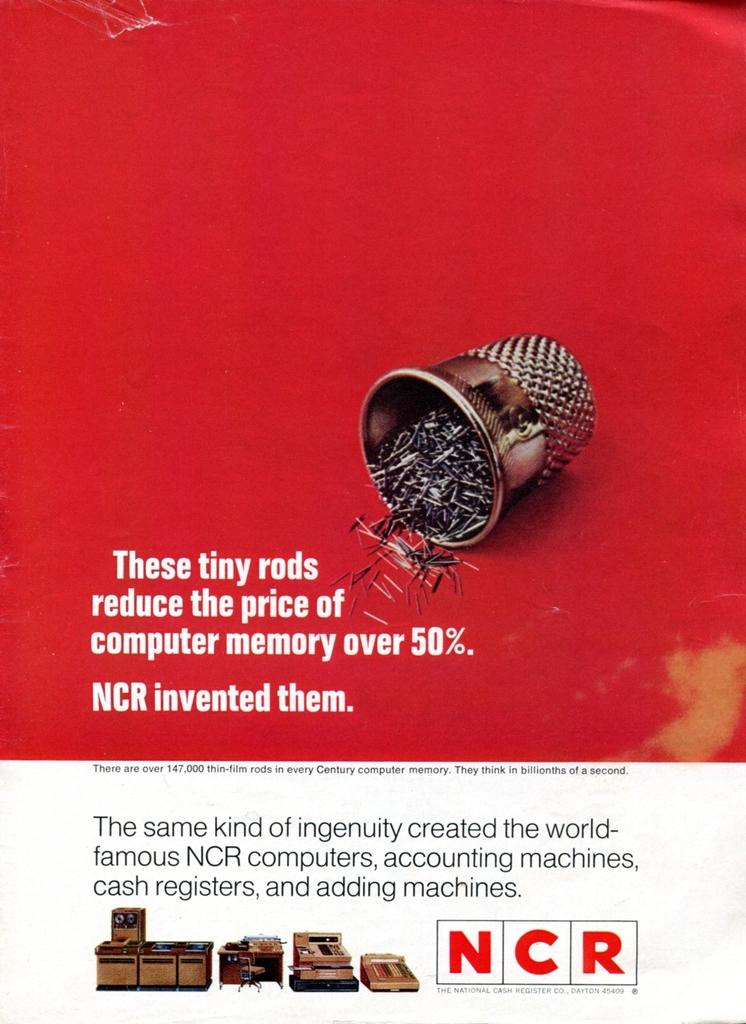What is present in the image that contains information or a message? There is a poster in the image that contains text. What else can be seen on the poster besides the text? The poster contains objects as well. What type of cloud is depicted on the poster? There is no cloud depicted on the poster; it contains text and objects. Is there a dog visible on the poster? There is no dog present on the poster; it contains text and objects. 